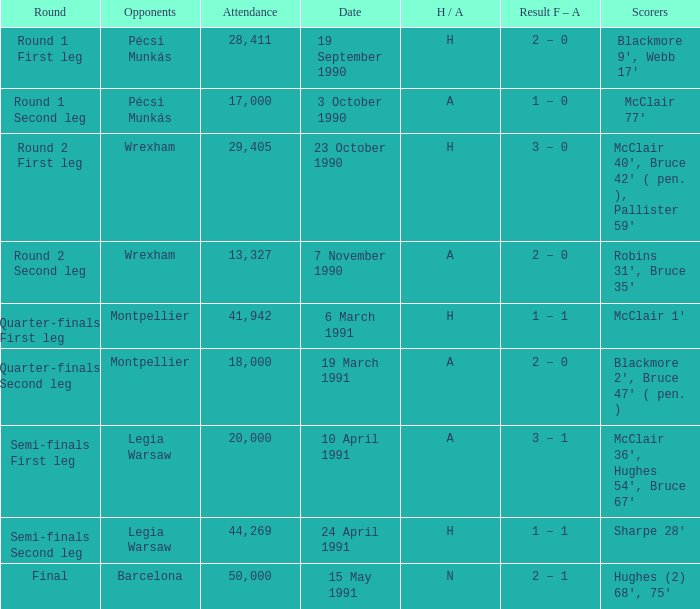What is the opponent name when the H/A is h with more than 28,411 in attendance and Sharpe 28' is the scorer? Legia Warsaw. 